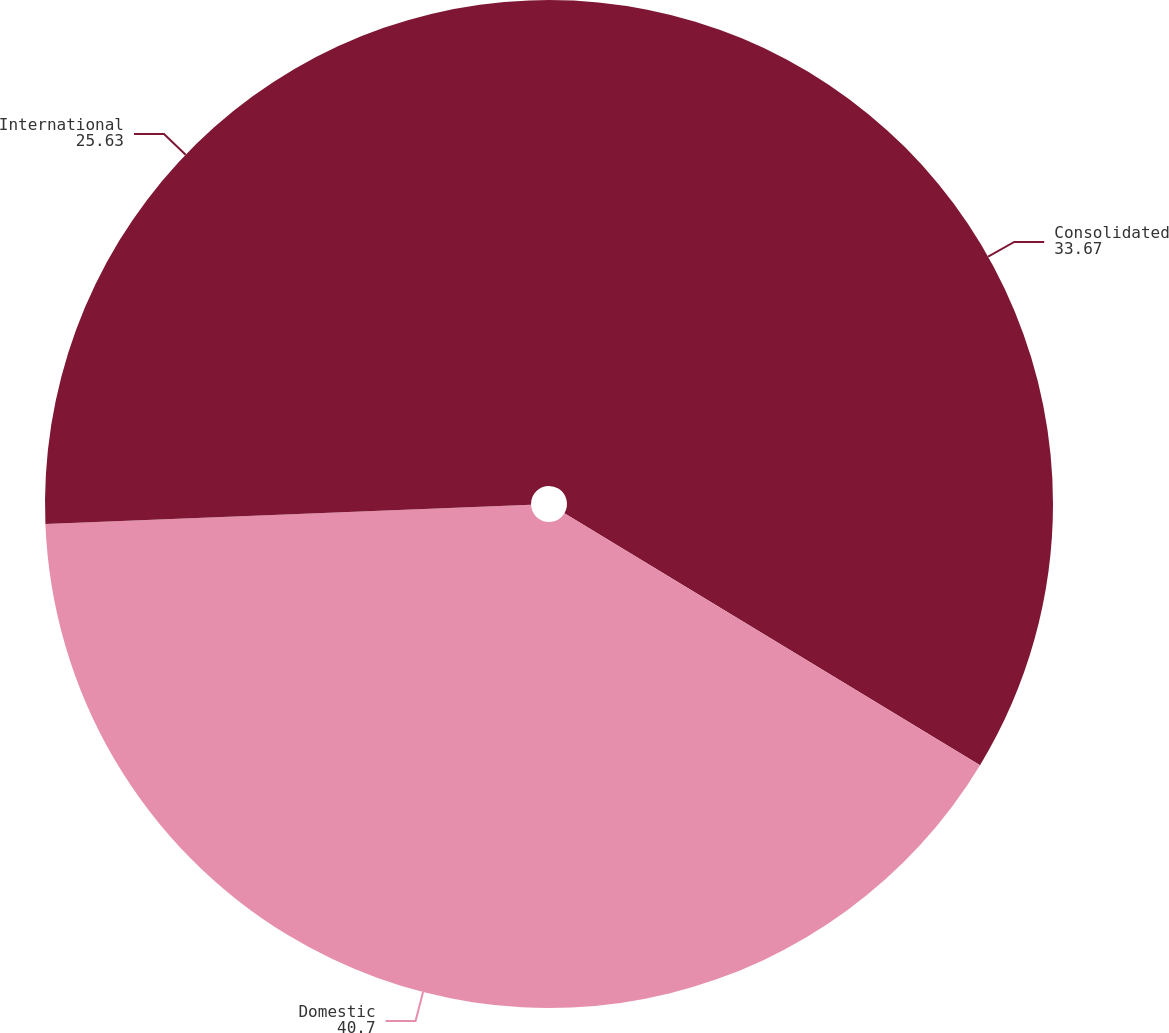<chart> <loc_0><loc_0><loc_500><loc_500><pie_chart><fcel>Consolidated<fcel>Domestic<fcel>International<nl><fcel>33.67%<fcel>40.7%<fcel>25.63%<nl></chart> 